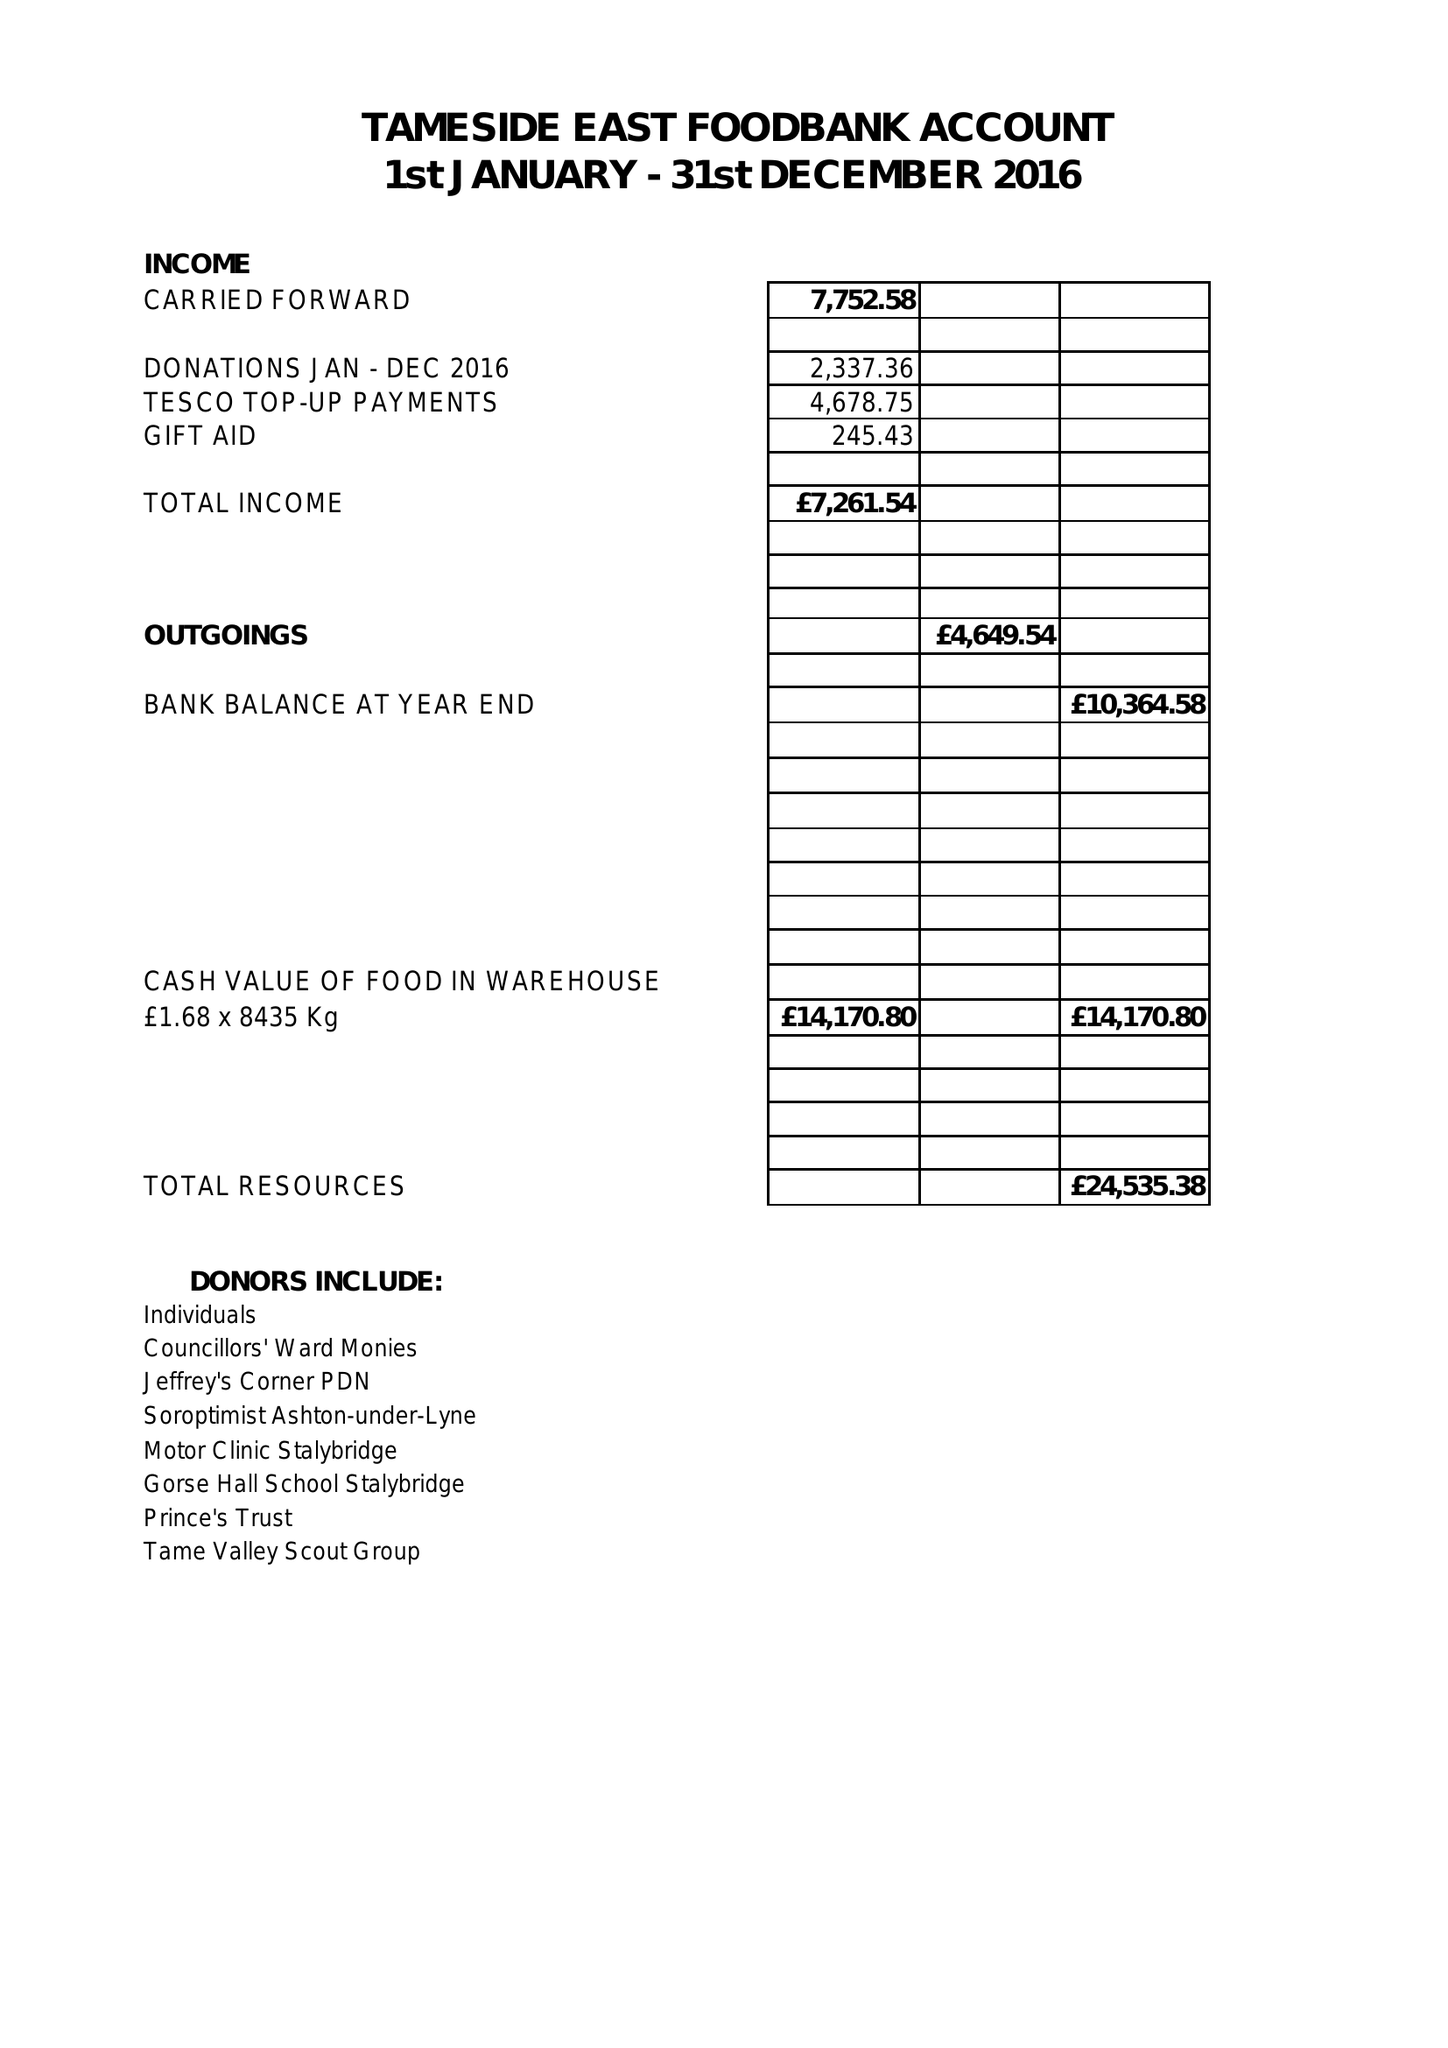What is the value for the address__postcode?
Answer the question using a single word or phrase. SK15 2JS 